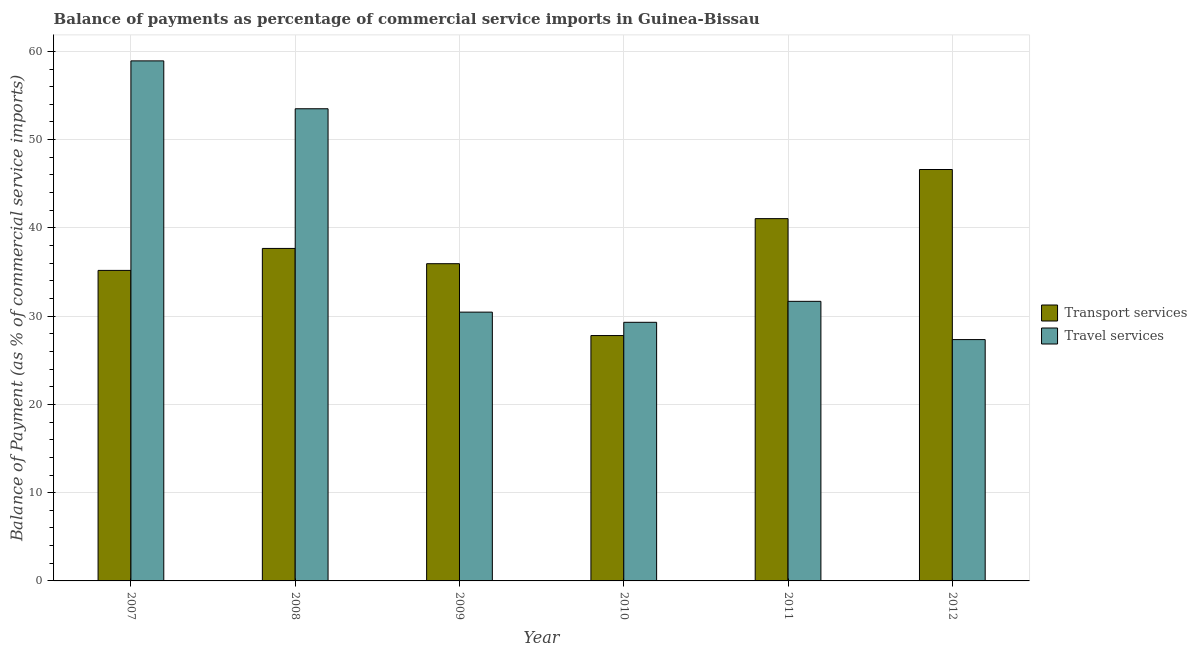What is the label of the 4th group of bars from the left?
Your answer should be very brief. 2010. What is the balance of payments of travel services in 2010?
Offer a terse response. 29.3. Across all years, what is the maximum balance of payments of travel services?
Keep it short and to the point. 58.92. Across all years, what is the minimum balance of payments of travel services?
Give a very brief answer. 27.34. In which year was the balance of payments of travel services maximum?
Provide a succinct answer. 2007. What is the total balance of payments of transport services in the graph?
Your answer should be very brief. 224.27. What is the difference between the balance of payments of travel services in 2009 and that in 2010?
Your answer should be compact. 1.15. What is the difference between the balance of payments of transport services in 2008 and the balance of payments of travel services in 2009?
Offer a very short reply. 1.73. What is the average balance of payments of travel services per year?
Provide a short and direct response. 38.53. In the year 2011, what is the difference between the balance of payments of travel services and balance of payments of transport services?
Make the answer very short. 0. What is the ratio of the balance of payments of travel services in 2007 to that in 2009?
Keep it short and to the point. 1.93. What is the difference between the highest and the second highest balance of payments of travel services?
Provide a short and direct response. 5.43. What is the difference between the highest and the lowest balance of payments of transport services?
Offer a terse response. 18.82. In how many years, is the balance of payments of travel services greater than the average balance of payments of travel services taken over all years?
Keep it short and to the point. 2. Is the sum of the balance of payments of travel services in 2007 and 2010 greater than the maximum balance of payments of transport services across all years?
Make the answer very short. Yes. What does the 2nd bar from the left in 2008 represents?
Make the answer very short. Travel services. What does the 2nd bar from the right in 2010 represents?
Your answer should be very brief. Transport services. How many bars are there?
Keep it short and to the point. 12. Are all the bars in the graph horizontal?
Provide a succinct answer. No. What is the difference between two consecutive major ticks on the Y-axis?
Ensure brevity in your answer.  10. Does the graph contain any zero values?
Give a very brief answer. No. Where does the legend appear in the graph?
Make the answer very short. Center right. What is the title of the graph?
Make the answer very short. Balance of payments as percentage of commercial service imports in Guinea-Bissau. What is the label or title of the X-axis?
Make the answer very short. Year. What is the label or title of the Y-axis?
Provide a short and direct response. Balance of Payment (as % of commercial service imports). What is the Balance of Payment (as % of commercial service imports) in Transport services in 2007?
Ensure brevity in your answer.  35.18. What is the Balance of Payment (as % of commercial service imports) of Travel services in 2007?
Provide a succinct answer. 58.92. What is the Balance of Payment (as % of commercial service imports) in Transport services in 2008?
Give a very brief answer. 37.67. What is the Balance of Payment (as % of commercial service imports) of Travel services in 2008?
Make the answer very short. 53.5. What is the Balance of Payment (as % of commercial service imports) in Transport services in 2009?
Your answer should be compact. 35.94. What is the Balance of Payment (as % of commercial service imports) in Travel services in 2009?
Make the answer very short. 30.46. What is the Balance of Payment (as % of commercial service imports) in Transport services in 2010?
Your response must be concise. 27.8. What is the Balance of Payment (as % of commercial service imports) of Travel services in 2010?
Make the answer very short. 29.3. What is the Balance of Payment (as % of commercial service imports) of Transport services in 2011?
Ensure brevity in your answer.  41.05. What is the Balance of Payment (as % of commercial service imports) of Travel services in 2011?
Your answer should be compact. 31.68. What is the Balance of Payment (as % of commercial service imports) in Transport services in 2012?
Offer a terse response. 46.62. What is the Balance of Payment (as % of commercial service imports) in Travel services in 2012?
Give a very brief answer. 27.34. Across all years, what is the maximum Balance of Payment (as % of commercial service imports) of Transport services?
Offer a very short reply. 46.62. Across all years, what is the maximum Balance of Payment (as % of commercial service imports) of Travel services?
Provide a short and direct response. 58.92. Across all years, what is the minimum Balance of Payment (as % of commercial service imports) of Transport services?
Offer a very short reply. 27.8. Across all years, what is the minimum Balance of Payment (as % of commercial service imports) in Travel services?
Keep it short and to the point. 27.34. What is the total Balance of Payment (as % of commercial service imports) in Transport services in the graph?
Your response must be concise. 224.27. What is the total Balance of Payment (as % of commercial service imports) in Travel services in the graph?
Provide a short and direct response. 231.21. What is the difference between the Balance of Payment (as % of commercial service imports) in Transport services in 2007 and that in 2008?
Keep it short and to the point. -2.49. What is the difference between the Balance of Payment (as % of commercial service imports) in Travel services in 2007 and that in 2008?
Your response must be concise. 5.43. What is the difference between the Balance of Payment (as % of commercial service imports) in Transport services in 2007 and that in 2009?
Ensure brevity in your answer.  -0.76. What is the difference between the Balance of Payment (as % of commercial service imports) of Travel services in 2007 and that in 2009?
Your answer should be very brief. 28.47. What is the difference between the Balance of Payment (as % of commercial service imports) in Transport services in 2007 and that in 2010?
Keep it short and to the point. 7.38. What is the difference between the Balance of Payment (as % of commercial service imports) in Travel services in 2007 and that in 2010?
Your response must be concise. 29.62. What is the difference between the Balance of Payment (as % of commercial service imports) of Transport services in 2007 and that in 2011?
Your answer should be very brief. -5.87. What is the difference between the Balance of Payment (as % of commercial service imports) in Travel services in 2007 and that in 2011?
Keep it short and to the point. 27.24. What is the difference between the Balance of Payment (as % of commercial service imports) in Transport services in 2007 and that in 2012?
Your answer should be compact. -11.43. What is the difference between the Balance of Payment (as % of commercial service imports) in Travel services in 2007 and that in 2012?
Provide a succinct answer. 31.58. What is the difference between the Balance of Payment (as % of commercial service imports) in Transport services in 2008 and that in 2009?
Offer a terse response. 1.73. What is the difference between the Balance of Payment (as % of commercial service imports) in Travel services in 2008 and that in 2009?
Offer a terse response. 23.04. What is the difference between the Balance of Payment (as % of commercial service imports) in Transport services in 2008 and that in 2010?
Offer a very short reply. 9.87. What is the difference between the Balance of Payment (as % of commercial service imports) of Travel services in 2008 and that in 2010?
Offer a very short reply. 24.2. What is the difference between the Balance of Payment (as % of commercial service imports) in Transport services in 2008 and that in 2011?
Give a very brief answer. -3.38. What is the difference between the Balance of Payment (as % of commercial service imports) in Travel services in 2008 and that in 2011?
Keep it short and to the point. 21.82. What is the difference between the Balance of Payment (as % of commercial service imports) in Transport services in 2008 and that in 2012?
Keep it short and to the point. -8.94. What is the difference between the Balance of Payment (as % of commercial service imports) in Travel services in 2008 and that in 2012?
Keep it short and to the point. 26.15. What is the difference between the Balance of Payment (as % of commercial service imports) of Transport services in 2009 and that in 2010?
Ensure brevity in your answer.  8.14. What is the difference between the Balance of Payment (as % of commercial service imports) of Travel services in 2009 and that in 2010?
Your answer should be compact. 1.15. What is the difference between the Balance of Payment (as % of commercial service imports) in Transport services in 2009 and that in 2011?
Your answer should be very brief. -5.11. What is the difference between the Balance of Payment (as % of commercial service imports) in Travel services in 2009 and that in 2011?
Offer a very short reply. -1.22. What is the difference between the Balance of Payment (as % of commercial service imports) of Transport services in 2009 and that in 2012?
Offer a very short reply. -10.67. What is the difference between the Balance of Payment (as % of commercial service imports) in Travel services in 2009 and that in 2012?
Keep it short and to the point. 3.11. What is the difference between the Balance of Payment (as % of commercial service imports) in Transport services in 2010 and that in 2011?
Your answer should be compact. -13.25. What is the difference between the Balance of Payment (as % of commercial service imports) of Travel services in 2010 and that in 2011?
Make the answer very short. -2.38. What is the difference between the Balance of Payment (as % of commercial service imports) in Transport services in 2010 and that in 2012?
Your answer should be very brief. -18.82. What is the difference between the Balance of Payment (as % of commercial service imports) of Travel services in 2010 and that in 2012?
Your response must be concise. 1.96. What is the difference between the Balance of Payment (as % of commercial service imports) in Transport services in 2011 and that in 2012?
Your answer should be compact. -5.57. What is the difference between the Balance of Payment (as % of commercial service imports) of Travel services in 2011 and that in 2012?
Make the answer very short. 4.33. What is the difference between the Balance of Payment (as % of commercial service imports) of Transport services in 2007 and the Balance of Payment (as % of commercial service imports) of Travel services in 2008?
Your answer should be compact. -18.31. What is the difference between the Balance of Payment (as % of commercial service imports) of Transport services in 2007 and the Balance of Payment (as % of commercial service imports) of Travel services in 2009?
Make the answer very short. 4.73. What is the difference between the Balance of Payment (as % of commercial service imports) in Transport services in 2007 and the Balance of Payment (as % of commercial service imports) in Travel services in 2010?
Make the answer very short. 5.88. What is the difference between the Balance of Payment (as % of commercial service imports) of Transport services in 2007 and the Balance of Payment (as % of commercial service imports) of Travel services in 2011?
Keep it short and to the point. 3.5. What is the difference between the Balance of Payment (as % of commercial service imports) in Transport services in 2007 and the Balance of Payment (as % of commercial service imports) in Travel services in 2012?
Give a very brief answer. 7.84. What is the difference between the Balance of Payment (as % of commercial service imports) of Transport services in 2008 and the Balance of Payment (as % of commercial service imports) of Travel services in 2009?
Provide a short and direct response. 7.22. What is the difference between the Balance of Payment (as % of commercial service imports) of Transport services in 2008 and the Balance of Payment (as % of commercial service imports) of Travel services in 2010?
Your answer should be compact. 8.37. What is the difference between the Balance of Payment (as % of commercial service imports) of Transport services in 2008 and the Balance of Payment (as % of commercial service imports) of Travel services in 2011?
Your answer should be compact. 5.99. What is the difference between the Balance of Payment (as % of commercial service imports) of Transport services in 2008 and the Balance of Payment (as % of commercial service imports) of Travel services in 2012?
Provide a succinct answer. 10.33. What is the difference between the Balance of Payment (as % of commercial service imports) in Transport services in 2009 and the Balance of Payment (as % of commercial service imports) in Travel services in 2010?
Your response must be concise. 6.64. What is the difference between the Balance of Payment (as % of commercial service imports) of Transport services in 2009 and the Balance of Payment (as % of commercial service imports) of Travel services in 2011?
Your response must be concise. 4.26. What is the difference between the Balance of Payment (as % of commercial service imports) of Transport services in 2009 and the Balance of Payment (as % of commercial service imports) of Travel services in 2012?
Provide a short and direct response. 8.6. What is the difference between the Balance of Payment (as % of commercial service imports) in Transport services in 2010 and the Balance of Payment (as % of commercial service imports) in Travel services in 2011?
Ensure brevity in your answer.  -3.88. What is the difference between the Balance of Payment (as % of commercial service imports) of Transport services in 2010 and the Balance of Payment (as % of commercial service imports) of Travel services in 2012?
Ensure brevity in your answer.  0.46. What is the difference between the Balance of Payment (as % of commercial service imports) of Transport services in 2011 and the Balance of Payment (as % of commercial service imports) of Travel services in 2012?
Give a very brief answer. 13.71. What is the average Balance of Payment (as % of commercial service imports) in Transport services per year?
Your answer should be very brief. 37.38. What is the average Balance of Payment (as % of commercial service imports) of Travel services per year?
Offer a very short reply. 38.53. In the year 2007, what is the difference between the Balance of Payment (as % of commercial service imports) in Transport services and Balance of Payment (as % of commercial service imports) in Travel services?
Make the answer very short. -23.74. In the year 2008, what is the difference between the Balance of Payment (as % of commercial service imports) of Transport services and Balance of Payment (as % of commercial service imports) of Travel services?
Make the answer very short. -15.83. In the year 2009, what is the difference between the Balance of Payment (as % of commercial service imports) in Transport services and Balance of Payment (as % of commercial service imports) in Travel services?
Your response must be concise. 5.49. In the year 2010, what is the difference between the Balance of Payment (as % of commercial service imports) of Transport services and Balance of Payment (as % of commercial service imports) of Travel services?
Make the answer very short. -1.5. In the year 2011, what is the difference between the Balance of Payment (as % of commercial service imports) of Transport services and Balance of Payment (as % of commercial service imports) of Travel services?
Keep it short and to the point. 9.37. In the year 2012, what is the difference between the Balance of Payment (as % of commercial service imports) in Transport services and Balance of Payment (as % of commercial service imports) in Travel services?
Provide a short and direct response. 19.27. What is the ratio of the Balance of Payment (as % of commercial service imports) in Transport services in 2007 to that in 2008?
Ensure brevity in your answer.  0.93. What is the ratio of the Balance of Payment (as % of commercial service imports) of Travel services in 2007 to that in 2008?
Offer a terse response. 1.1. What is the ratio of the Balance of Payment (as % of commercial service imports) in Transport services in 2007 to that in 2009?
Keep it short and to the point. 0.98. What is the ratio of the Balance of Payment (as % of commercial service imports) of Travel services in 2007 to that in 2009?
Your answer should be very brief. 1.93. What is the ratio of the Balance of Payment (as % of commercial service imports) in Transport services in 2007 to that in 2010?
Ensure brevity in your answer.  1.27. What is the ratio of the Balance of Payment (as % of commercial service imports) of Travel services in 2007 to that in 2010?
Your answer should be very brief. 2.01. What is the ratio of the Balance of Payment (as % of commercial service imports) of Travel services in 2007 to that in 2011?
Ensure brevity in your answer.  1.86. What is the ratio of the Balance of Payment (as % of commercial service imports) in Transport services in 2007 to that in 2012?
Make the answer very short. 0.75. What is the ratio of the Balance of Payment (as % of commercial service imports) of Travel services in 2007 to that in 2012?
Give a very brief answer. 2.15. What is the ratio of the Balance of Payment (as % of commercial service imports) in Transport services in 2008 to that in 2009?
Offer a very short reply. 1.05. What is the ratio of the Balance of Payment (as % of commercial service imports) of Travel services in 2008 to that in 2009?
Offer a terse response. 1.76. What is the ratio of the Balance of Payment (as % of commercial service imports) of Transport services in 2008 to that in 2010?
Your answer should be compact. 1.36. What is the ratio of the Balance of Payment (as % of commercial service imports) of Travel services in 2008 to that in 2010?
Offer a very short reply. 1.83. What is the ratio of the Balance of Payment (as % of commercial service imports) in Transport services in 2008 to that in 2011?
Your answer should be very brief. 0.92. What is the ratio of the Balance of Payment (as % of commercial service imports) of Travel services in 2008 to that in 2011?
Provide a succinct answer. 1.69. What is the ratio of the Balance of Payment (as % of commercial service imports) in Transport services in 2008 to that in 2012?
Provide a succinct answer. 0.81. What is the ratio of the Balance of Payment (as % of commercial service imports) in Travel services in 2008 to that in 2012?
Provide a succinct answer. 1.96. What is the ratio of the Balance of Payment (as % of commercial service imports) of Transport services in 2009 to that in 2010?
Give a very brief answer. 1.29. What is the ratio of the Balance of Payment (as % of commercial service imports) of Travel services in 2009 to that in 2010?
Offer a terse response. 1.04. What is the ratio of the Balance of Payment (as % of commercial service imports) in Transport services in 2009 to that in 2011?
Ensure brevity in your answer.  0.88. What is the ratio of the Balance of Payment (as % of commercial service imports) of Travel services in 2009 to that in 2011?
Your answer should be very brief. 0.96. What is the ratio of the Balance of Payment (as % of commercial service imports) in Transport services in 2009 to that in 2012?
Ensure brevity in your answer.  0.77. What is the ratio of the Balance of Payment (as % of commercial service imports) of Travel services in 2009 to that in 2012?
Your answer should be compact. 1.11. What is the ratio of the Balance of Payment (as % of commercial service imports) of Transport services in 2010 to that in 2011?
Ensure brevity in your answer.  0.68. What is the ratio of the Balance of Payment (as % of commercial service imports) of Travel services in 2010 to that in 2011?
Ensure brevity in your answer.  0.93. What is the ratio of the Balance of Payment (as % of commercial service imports) of Transport services in 2010 to that in 2012?
Offer a terse response. 0.6. What is the ratio of the Balance of Payment (as % of commercial service imports) of Travel services in 2010 to that in 2012?
Offer a terse response. 1.07. What is the ratio of the Balance of Payment (as % of commercial service imports) in Transport services in 2011 to that in 2012?
Make the answer very short. 0.88. What is the ratio of the Balance of Payment (as % of commercial service imports) in Travel services in 2011 to that in 2012?
Provide a short and direct response. 1.16. What is the difference between the highest and the second highest Balance of Payment (as % of commercial service imports) in Transport services?
Your answer should be compact. 5.57. What is the difference between the highest and the second highest Balance of Payment (as % of commercial service imports) in Travel services?
Give a very brief answer. 5.43. What is the difference between the highest and the lowest Balance of Payment (as % of commercial service imports) in Transport services?
Make the answer very short. 18.82. What is the difference between the highest and the lowest Balance of Payment (as % of commercial service imports) of Travel services?
Offer a terse response. 31.58. 